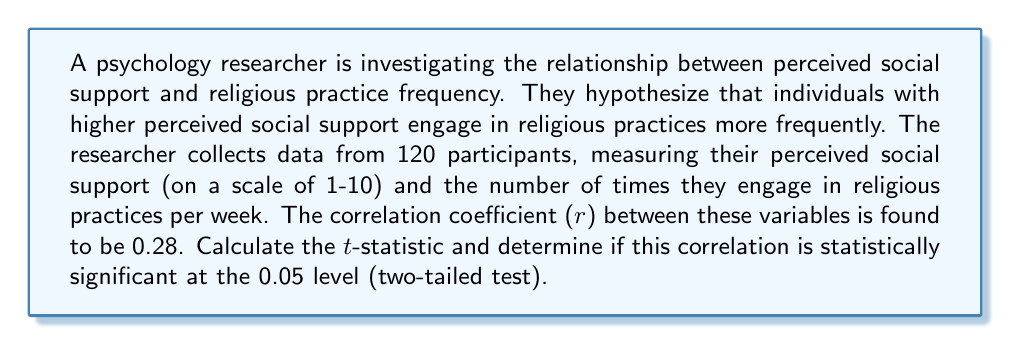Can you answer this question? To determine the statistical significance of the correlation, we need to follow these steps:

1. State the null and alternative hypotheses:
   $H_0: \rho = 0$ (no correlation in the population)
   $H_a: \rho \neq 0$ (correlation exists in the population)

2. Calculate the t-statistic using the formula:
   $t = \frac{r\sqrt{n-2}}{\sqrt{1-r^2}}$

   Where:
   $r$ = sample correlation coefficient
   $n$ = sample size

3. Substitute the given values:
   $r = 0.28$
   $n = 120$

4. Calculate the t-statistic:
   $t = \frac{0.28\sqrt{120-2}}{\sqrt{1-0.28^2}}$
   $t = \frac{0.28\sqrt{118}}{\sqrt{1-0.0784}}$
   $t = \frac{0.28 \cdot 10.8628}{0.9619}$
   $t = 3.1672$

5. Determine the critical t-value:
   For a two-tailed test at α = 0.05 with df = n - 2 = 118, the critical t-value is approximately ±1.98 (from t-distribution table).

6. Compare the calculated t-statistic to the critical value:
   $|3.1672| > 1.98$

7. Make a decision:
   Since the absolute value of the calculated t-statistic is greater than the critical value, we reject the null hypothesis.

Therefore, the correlation is statistically significant at the 0.05 level.
Answer: $t = 3.1672$; Statistically significant $(p < 0.05)$ 